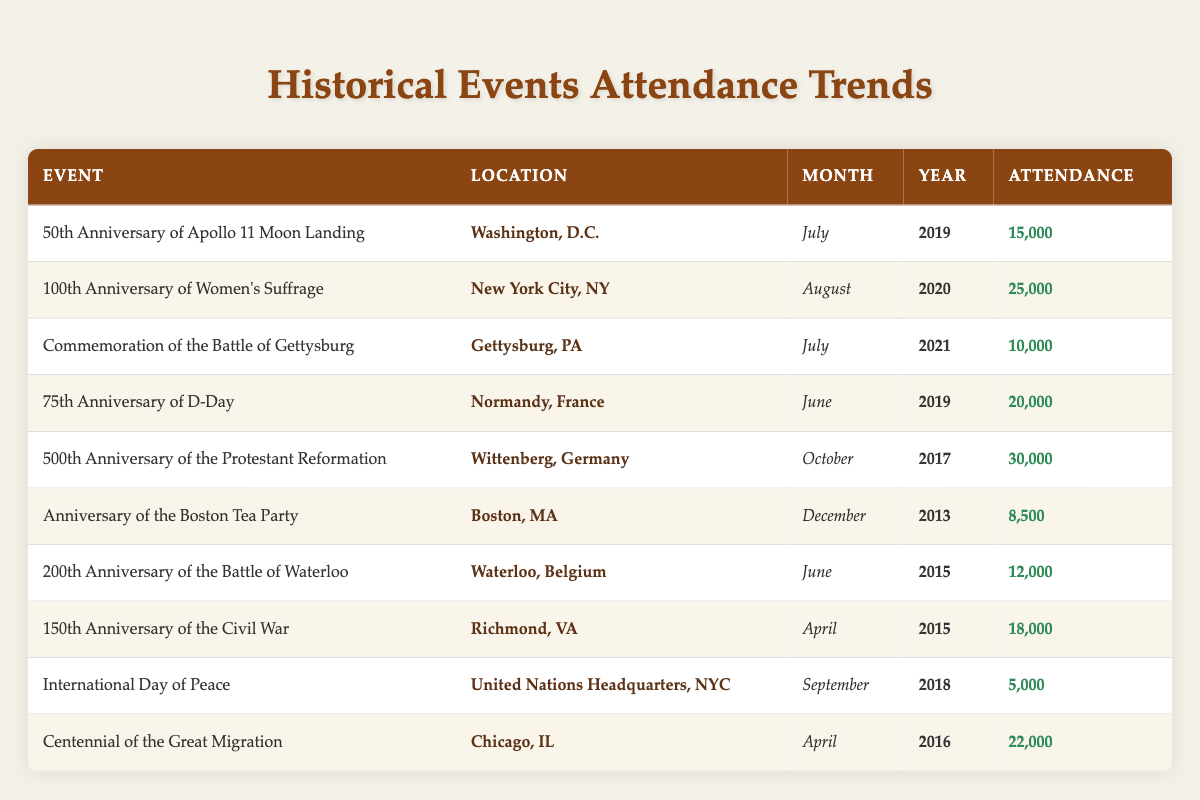What is the attendance for the 100th Anniversary of Women's Suffrage? The attendance figure for the 100th Anniversary of Women's Suffrage is listed in the row corresponding to this event. Looking directly at the table, we see that the attendance is 25,000.
Answer: 25,000 Which event had the lowest attendance, and what was that number? By reviewing the attendances listed in the table, we see that the event with the lowest attendance is the International Day of Peace, which had an attendance of 5,000.
Answer: International Day of Peace, 5,000 How many attendees were there in total for events held in April? To find the total attendance for events in April, we need to look at the rows where the month is April and sum the attendance figures. The events in April are: 18,000 for the 150th Anniversary of the Civil War and 22,000 for the Centennial of the Great Migration. Adding these gives us a total of 18,000 + 22,000 = 40,000.
Answer: 40,000 Was there an event held in August, and if so, what was its attendance? Looking at the events listed, there is indeed an event held in August, which is the 100th Anniversary of Women's Suffrage. Its attendance is 25,000.
Answer: Yes, 25,000 What is the average attendance for events held in June? We first identify the events that took place in June from the table. These are the 75th Anniversary of D-Day with 20,000 attendees and the 200th Anniversary of the Battle of Waterloo with 12,000 attendees. To find the average, we sum these two values: 20,000 + 12,000 = 32,000, and then divide by the number of events in June, which is 2. The average attendance is 32,000 / 2 = 16,000.
Answer: 16,000 How many events had an attendance of over 20,000? By scanning the attendance figures in the table, we note the events with more than 20,000 attendees: the 100th Anniversary of Women's Suffrage (25,000), the 75th Anniversary of D-Day (20,000), and the 500th Anniversary of the Protestant Reformation (30,000). Counting these, we find there are 3 events with attendance over 20,000.
Answer: 3 Which location had an event with the highest attendance, and what is that number? Inspecting the table, the highest attendance recorded is 30,000 for the event marking the 500th Anniversary of the Protestant Reformation in Wittenberg, Germany.
Answer: Wittenberg, Germany, 30,000 Did any events take place in both July 2019 and July 2021? Checking the table for events in July, we have the 50th Anniversary of Apollo 11 Moon Landing in July 2019 and the Commemoration of the Battle of Gettysburg in July 2021. Therefore, yes, there were events in both years in July.
Answer: Yes 